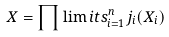<formula> <loc_0><loc_0><loc_500><loc_500>X = \prod \lim i t s _ { i = 1 } ^ { n } j _ { i } ( X _ { i } )</formula> 